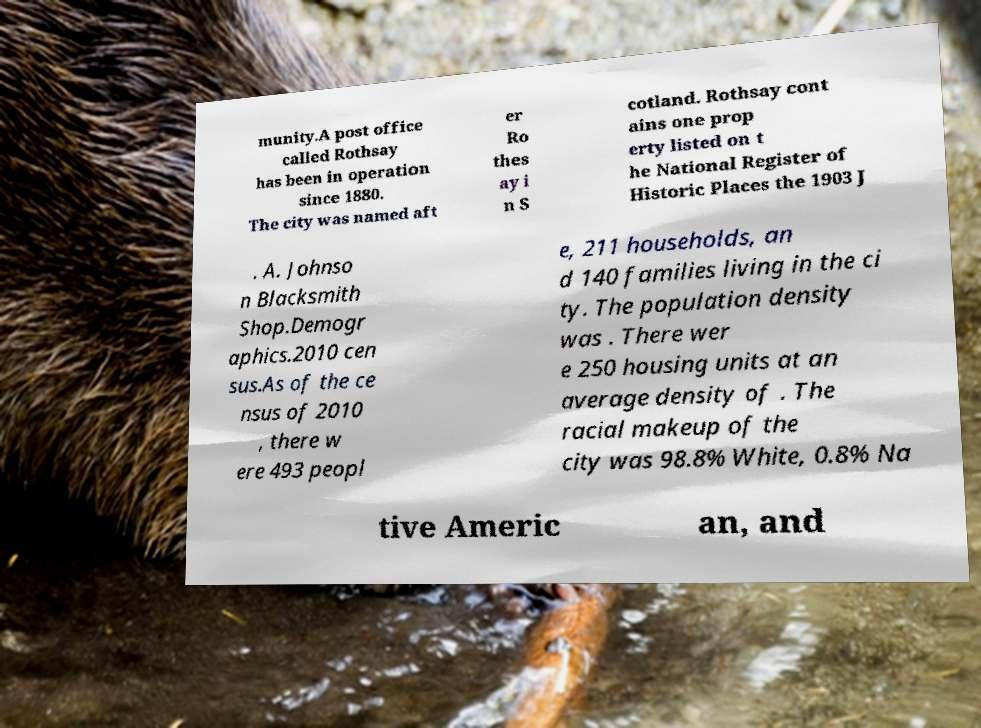For documentation purposes, I need the text within this image transcribed. Could you provide that? munity.A post office called Rothsay has been in operation since 1880. The city was named aft er Ro thes ay i n S cotland. Rothsay cont ains one prop erty listed on t he National Register of Historic Places the 1903 J . A. Johnso n Blacksmith Shop.Demogr aphics.2010 cen sus.As of the ce nsus of 2010 , there w ere 493 peopl e, 211 households, an d 140 families living in the ci ty. The population density was . There wer e 250 housing units at an average density of . The racial makeup of the city was 98.8% White, 0.8% Na tive Americ an, and 